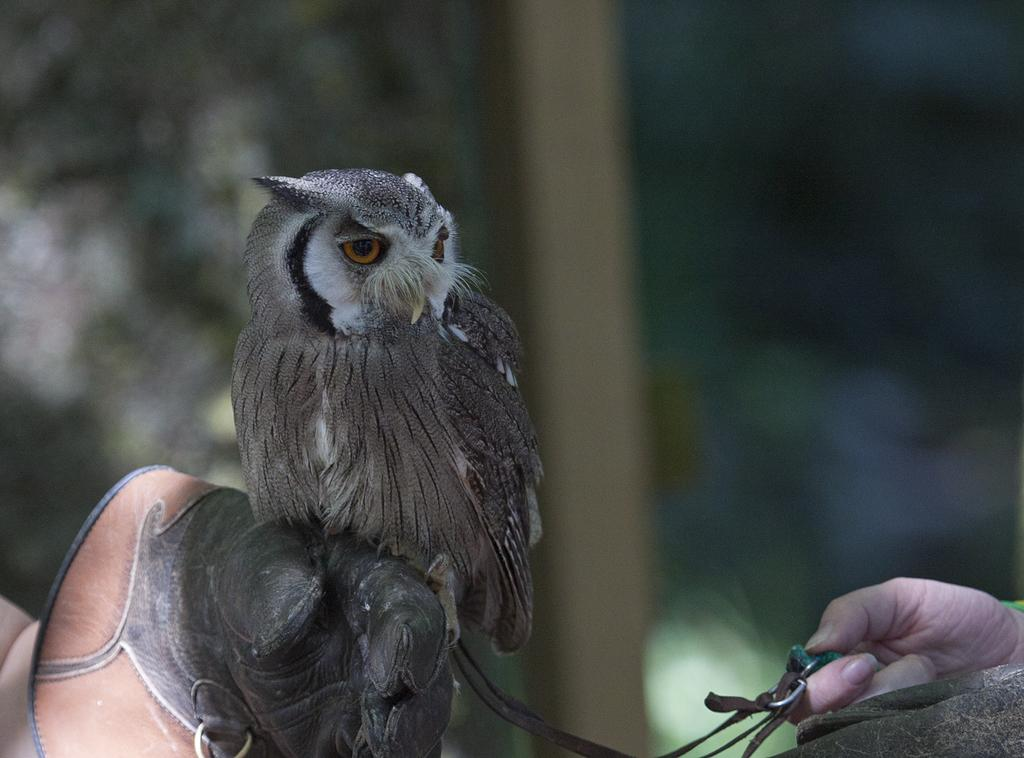What animal is in the image? There is an owl in the image. How is the owl being held in the image? The owl is on the hand of a person. What is the person wearing on their hand? The person is wearing a glove. What object is held by a hand in the image? There is a hand holding a belt in the image. On which side of the image is the hand with the belt located? The hand with the belt is on the right side of the image. What type of sheet is covering the owl in the image? There is no sheet present in the image. 